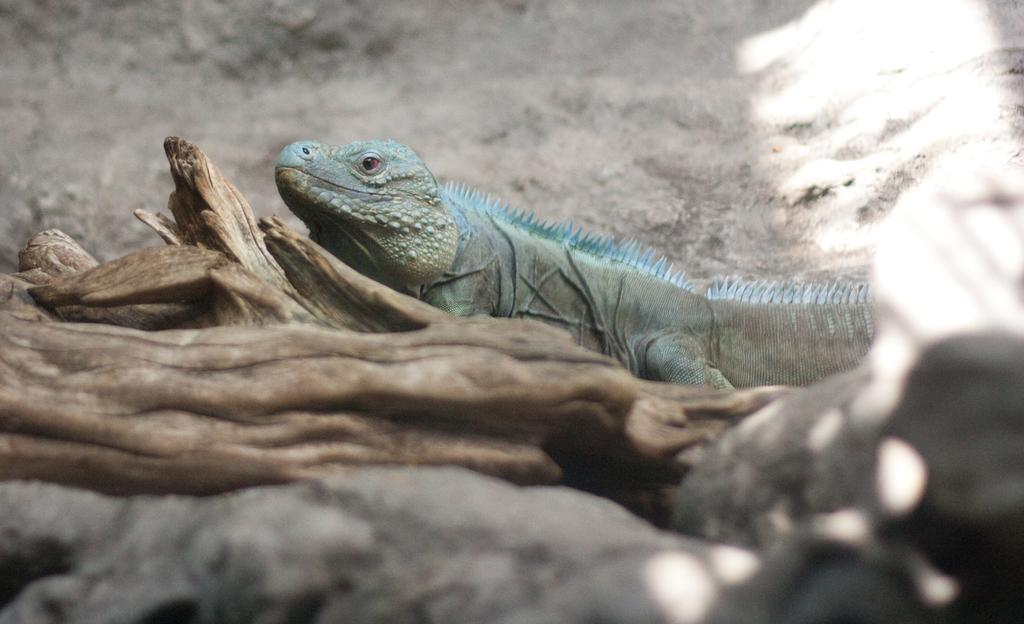What color is the animal in the image? The animal in the image is blue. What is the animal near in the image? The animal is near wooden sticks. How many children are playing with the base and spade in the image? There are no children, base, or spade present in the image. 